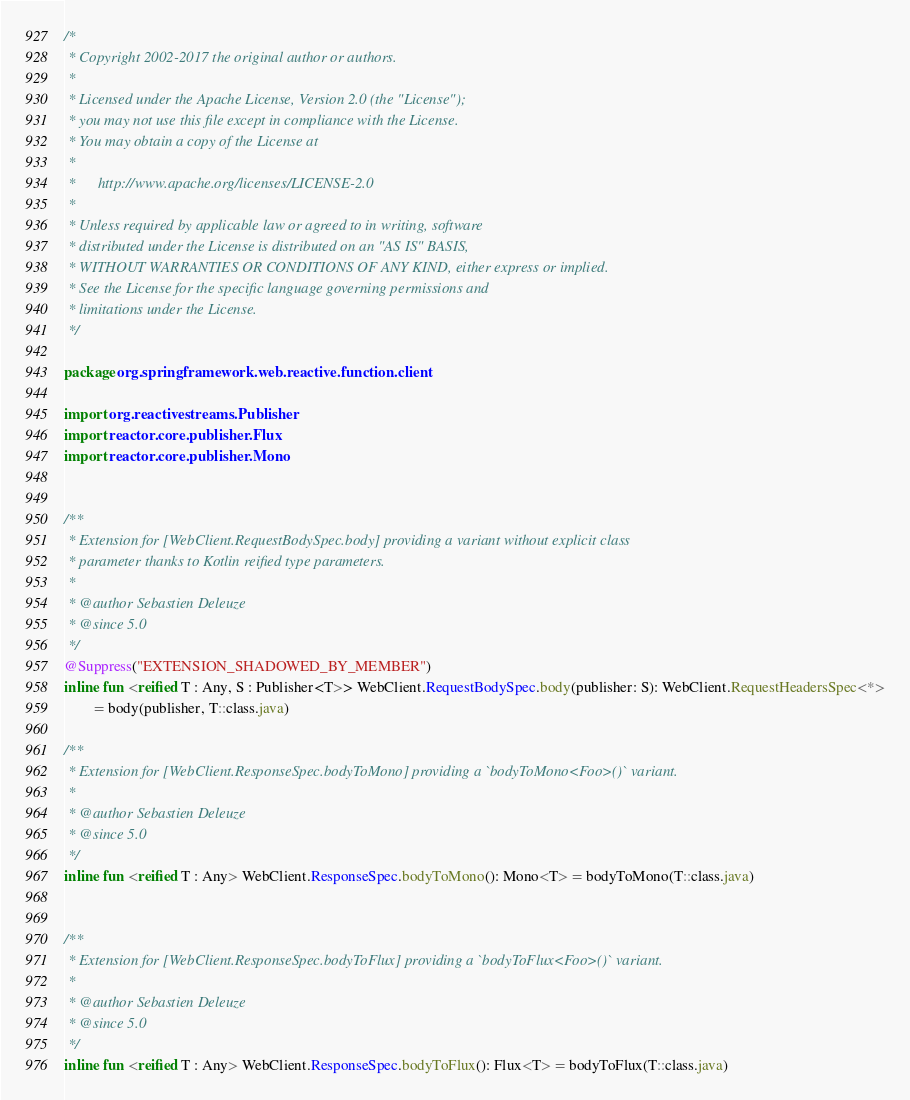<code> <loc_0><loc_0><loc_500><loc_500><_Kotlin_>/*
 * Copyright 2002-2017 the original author or authors.
 *
 * Licensed under the Apache License, Version 2.0 (the "License");
 * you may not use this file except in compliance with the License.
 * You may obtain a copy of the License at
 *
 *      http://www.apache.org/licenses/LICENSE-2.0
 *
 * Unless required by applicable law or agreed to in writing, software
 * distributed under the License is distributed on an "AS IS" BASIS,
 * WITHOUT WARRANTIES OR CONDITIONS OF ANY KIND, either express or implied.
 * See the License for the specific language governing permissions and
 * limitations under the License.
 */

package org.springframework.web.reactive.function.client

import org.reactivestreams.Publisher
import reactor.core.publisher.Flux
import reactor.core.publisher.Mono


/**
 * Extension for [WebClient.RequestBodySpec.body] providing a variant without explicit class
 * parameter thanks to Kotlin reified type parameters.
 *
 * @author Sebastien Deleuze
 * @since 5.0
 */
@Suppress("EXTENSION_SHADOWED_BY_MEMBER")
inline fun <reified T : Any, S : Publisher<T>> WebClient.RequestBodySpec.body(publisher: S): WebClient.RequestHeadersSpec<*>
        = body(publisher, T::class.java)

/**
 * Extension for [WebClient.ResponseSpec.bodyToMono] providing a `bodyToMono<Foo>()` variant.
 *
 * @author Sebastien Deleuze
 * @since 5.0
 */
inline fun <reified T : Any> WebClient.ResponseSpec.bodyToMono(): Mono<T> = bodyToMono(T::class.java)


/**
 * Extension for [WebClient.ResponseSpec.bodyToFlux] providing a `bodyToFlux<Foo>()` variant.
 *
 * @author Sebastien Deleuze
 * @since 5.0
 */
inline fun <reified T : Any> WebClient.ResponseSpec.bodyToFlux(): Flux<T> = bodyToFlux(T::class.java)
</code> 